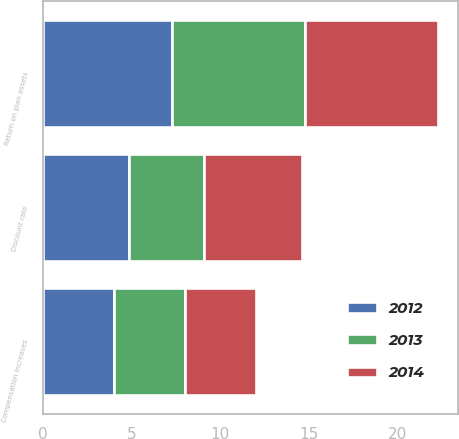<chart> <loc_0><loc_0><loc_500><loc_500><stacked_bar_chart><ecel><fcel>Discount rate<fcel>Compensation increases<fcel>Return on plan assets<nl><fcel>2012<fcel>4.85<fcel>4<fcel>7.25<nl><fcel>2013<fcel>4.25<fcel>4<fcel>7.5<nl><fcel>2014<fcel>5.5<fcel>4<fcel>7.5<nl></chart> 